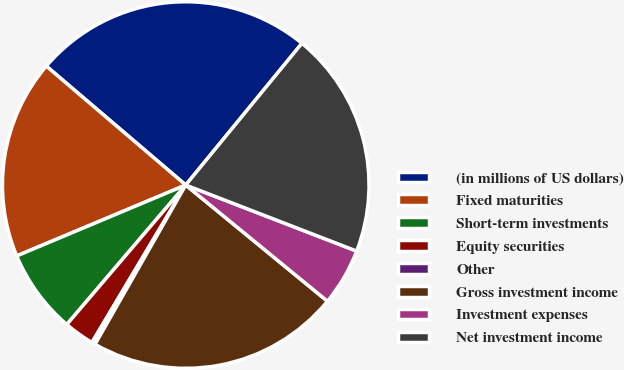Convert chart to OTSL. <chart><loc_0><loc_0><loc_500><loc_500><pie_chart><fcel>(in millions of US dollars)<fcel>Fixed maturities<fcel>Short-term investments<fcel>Equity securities<fcel>Other<fcel>Gross investment income<fcel>Investment expenses<fcel>Net investment income<nl><fcel>24.69%<fcel>17.56%<fcel>7.44%<fcel>2.69%<fcel>0.31%<fcel>22.31%<fcel>5.06%<fcel>19.94%<nl></chart> 